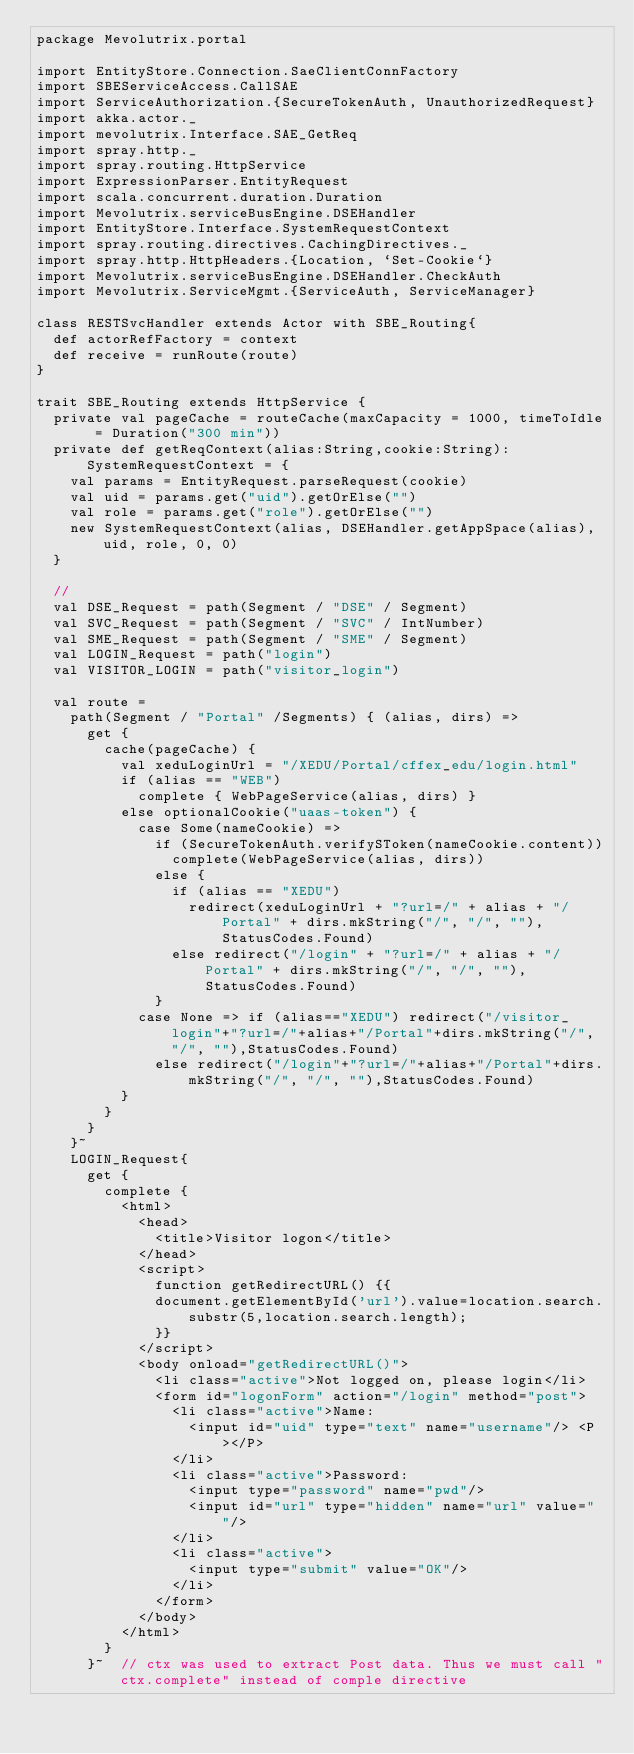Convert code to text. <code><loc_0><loc_0><loc_500><loc_500><_Scala_>package Mevolutrix.portal

import EntityStore.Connection.SaeClientConnFactory
import SBEServiceAccess.CallSAE
import ServiceAuthorization.{SecureTokenAuth, UnauthorizedRequest}
import akka.actor._
import mevolutrix.Interface.SAE_GetReq
import spray.http._
import spray.routing.HttpService
import ExpressionParser.EntityRequest
import scala.concurrent.duration.Duration
import Mevolutrix.serviceBusEngine.DSEHandler
import EntityStore.Interface.SystemRequestContext
import spray.routing.directives.CachingDirectives._
import spray.http.HttpHeaders.{Location, `Set-Cookie`}
import Mevolutrix.serviceBusEngine.DSEHandler.CheckAuth
import Mevolutrix.ServiceMgmt.{ServiceAuth, ServiceManager}

class RESTSvcHandler extends Actor with SBE_Routing{
  def actorRefFactory = context
  def receive = runRoute(route)
}

trait SBE_Routing extends HttpService {
  private val pageCache = routeCache(maxCapacity = 1000, timeToIdle = Duration("300 min"))
  private def getReqContext(alias:String,cookie:String):SystemRequestContext = {
    val params = EntityRequest.parseRequest(cookie)
    val uid = params.get("uid").getOrElse("")
    val role = params.get("role").getOrElse("")
    new SystemRequestContext(alias, DSEHandler.getAppSpace(alias), uid, role, 0, 0)
  }

  //
  val DSE_Request = path(Segment / "DSE" / Segment)
  val SVC_Request = path(Segment / "SVC" / IntNumber)
  val SME_Request = path(Segment / "SME" / Segment)
  val LOGIN_Request = path("login")
  val VISITOR_LOGIN = path("visitor_login")

  val route =
    path(Segment / "Portal" /Segments) { (alias, dirs) =>
      get {
        cache(pageCache) {
          val xeduLoginUrl = "/XEDU/Portal/cffex_edu/login.html"
          if (alias == "WEB")
            complete { WebPageService(alias, dirs) }
          else optionalCookie("uaas-token") {
            case Some(nameCookie) =>
              if (SecureTokenAuth.verifySToken(nameCookie.content))
                complete(WebPageService(alias, dirs))
              else {
                if (alias == "XEDU")
                  redirect(xeduLoginUrl + "?url=/" + alias + "/Portal" + dirs.mkString("/", "/", ""), StatusCodes.Found)
                else redirect("/login" + "?url=/" + alias + "/Portal" + dirs.mkString("/", "/", ""), StatusCodes.Found)
              }
            case None => if (alias=="XEDU") redirect("/visitor_login"+"?url=/"+alias+"/Portal"+dirs.mkString("/", "/", ""),StatusCodes.Found)
              else redirect("/login"+"?url=/"+alias+"/Portal"+dirs.mkString("/", "/", ""),StatusCodes.Found)
          }
        }
      }
    }~
    LOGIN_Request{
      get {
        complete {
          <html>
            <head>
              <title>Visitor logon</title>
            </head>
            <script>
              function getRedirectURL() {{
              document.getElementById('url').value=location.search.substr(5,location.search.length);
              }}
            </script>
            <body onload="getRedirectURL()">
              <li class="active">Not logged on, please login</li>
              <form id="logonForm" action="/login" method="post">
                <li class="active">Name:
                  <input id="uid" type="text" name="username"/> <P></P>
                </li>
                <li class="active">Password:
                  <input type="password" name="pwd"/>
                  <input id="url" type="hidden" name="url" value=" "/>
                </li>
                <li class="active">
                  <input type="submit" value="OK"/>
                </li>
              </form>
            </body>
          </html>
        }
      }~  // ctx was used to extract Post data. Thus we must call "ctx.complete" instead of comple directive</code> 